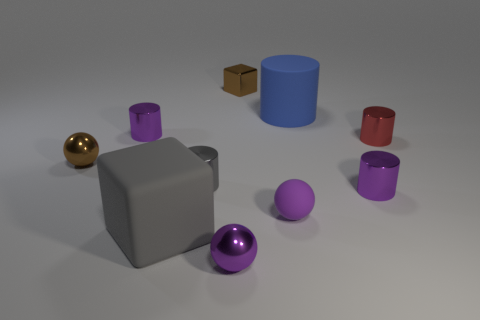What number of things are either small red objects or small purple cylinders to the left of the blue cylinder?
Make the answer very short. 2. Is there a gray matte cylinder of the same size as the gray rubber object?
Provide a short and direct response. No. Is the red cylinder made of the same material as the big gray thing?
Provide a short and direct response. No. How many objects are large green matte cubes or tiny shiny blocks?
Your answer should be compact. 1. How big is the blue thing?
Offer a very short reply. Large. Are there fewer small red objects than large gray metal spheres?
Provide a succinct answer. No. What number of other big cylinders are the same color as the matte cylinder?
Keep it short and to the point. 0. Is the color of the tiny cylinder behind the red cylinder the same as the small metallic cube?
Provide a short and direct response. No. What shape is the purple object that is to the left of the gray metallic object?
Offer a terse response. Cylinder. Is there a small brown shiny thing on the right side of the tiny metallic ball in front of the gray metal cylinder?
Offer a terse response. Yes. 